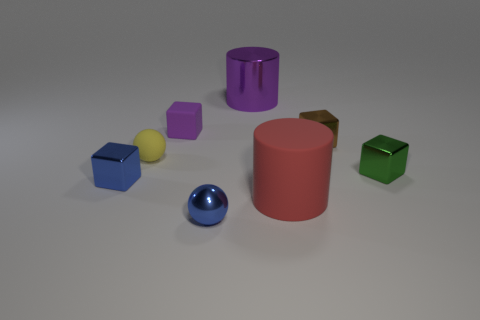Subtract all cyan blocks. Subtract all red cylinders. How many blocks are left? 4 Add 1 big purple cylinders. How many objects exist? 9 Subtract all balls. How many objects are left? 6 Add 6 purple rubber cubes. How many purple rubber cubes are left? 7 Add 2 red balls. How many red balls exist? 2 Subtract 0 green cylinders. How many objects are left? 8 Subtract all small purple cylinders. Subtract all matte cylinders. How many objects are left? 7 